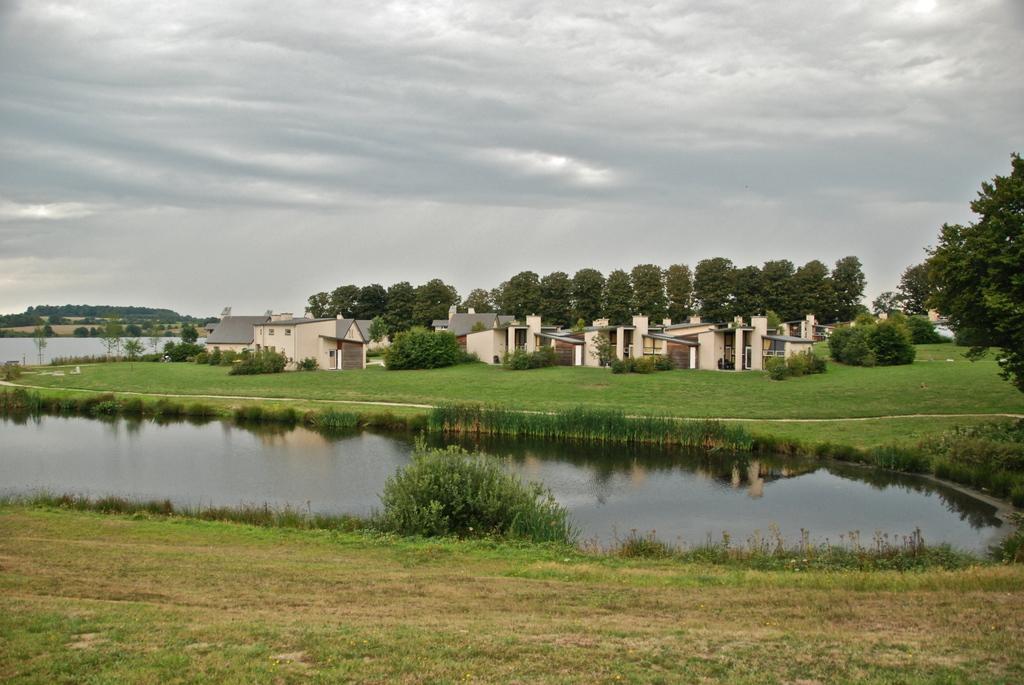In one or two sentences, can you explain what this image depicts? In this image we can see water. On the ground there is grass. In the back there there are buildings and trees. In the background there is sky with clouds. 